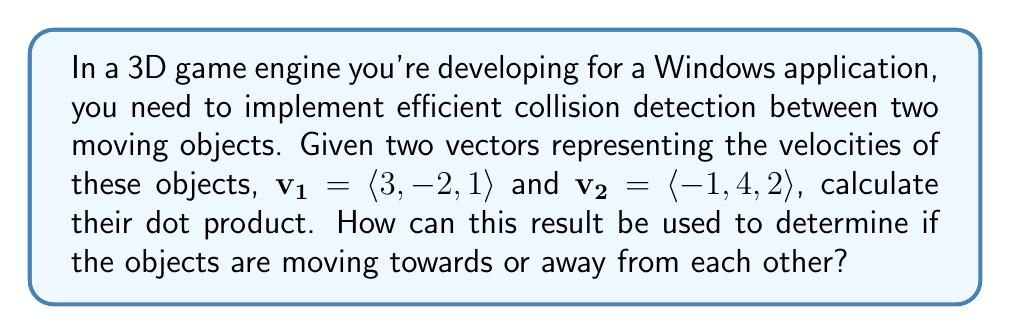Solve this math problem. To solve this problem, we'll follow these steps:

1. Recall the formula for the dot product of two vectors in 3D space:
   $$\mathbf{v_1} \cdot \mathbf{v_2} = x_1x_2 + y_1y_2 + z_1z_2$$

2. Substitute the given values:
   $\mathbf{v_1} = \langle 3, -2, 1 \rangle$
   $\mathbf{v_2} = \langle -1, 4, 2 \rangle$

3. Calculate each component:
   $$\begin{align*}
   x_1x_2 &= 3 \cdot (-1) = -3 \\
   y_1y_2 &= (-2) \cdot 4 = -8 \\
   z_1z_2 &= 1 \cdot 2 = 2
   \end{align*}$$

4. Sum up the components:
   $$\mathbf{v_1} \cdot \mathbf{v_2} = -3 + (-8) + 2 = -9$$

The dot product can be used to determine if objects are moving towards or away from each other:

- If the dot product is negative, the objects are moving towards each other.
- If the dot product is positive, the objects are moving away from each other.
- If the dot product is zero, the objects are moving perpendicular to each other.

In this case, the dot product is -9, which is negative. This indicates that the objects are moving towards each other, potentially leading to a collision.

This method is computationally efficient for collision detection in game engines, as it involves simple arithmetic operations and can be easily optimized for Windows applications using SIMD instructions or GPU acceleration if needed.
Answer: The dot product of $\mathbf{v_1}$ and $\mathbf{v_2}$ is -9. Since this value is negative, it indicates that the objects are moving towards each other, potentially leading to a collision. 